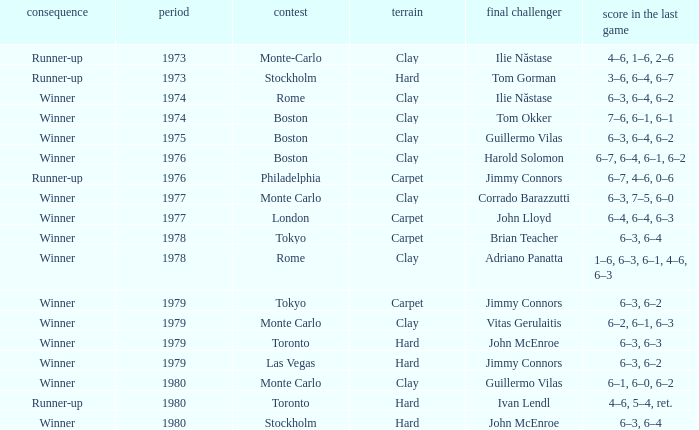Name the total number of opponent in the final for 6–2, 6–1, 6–3 1.0. 